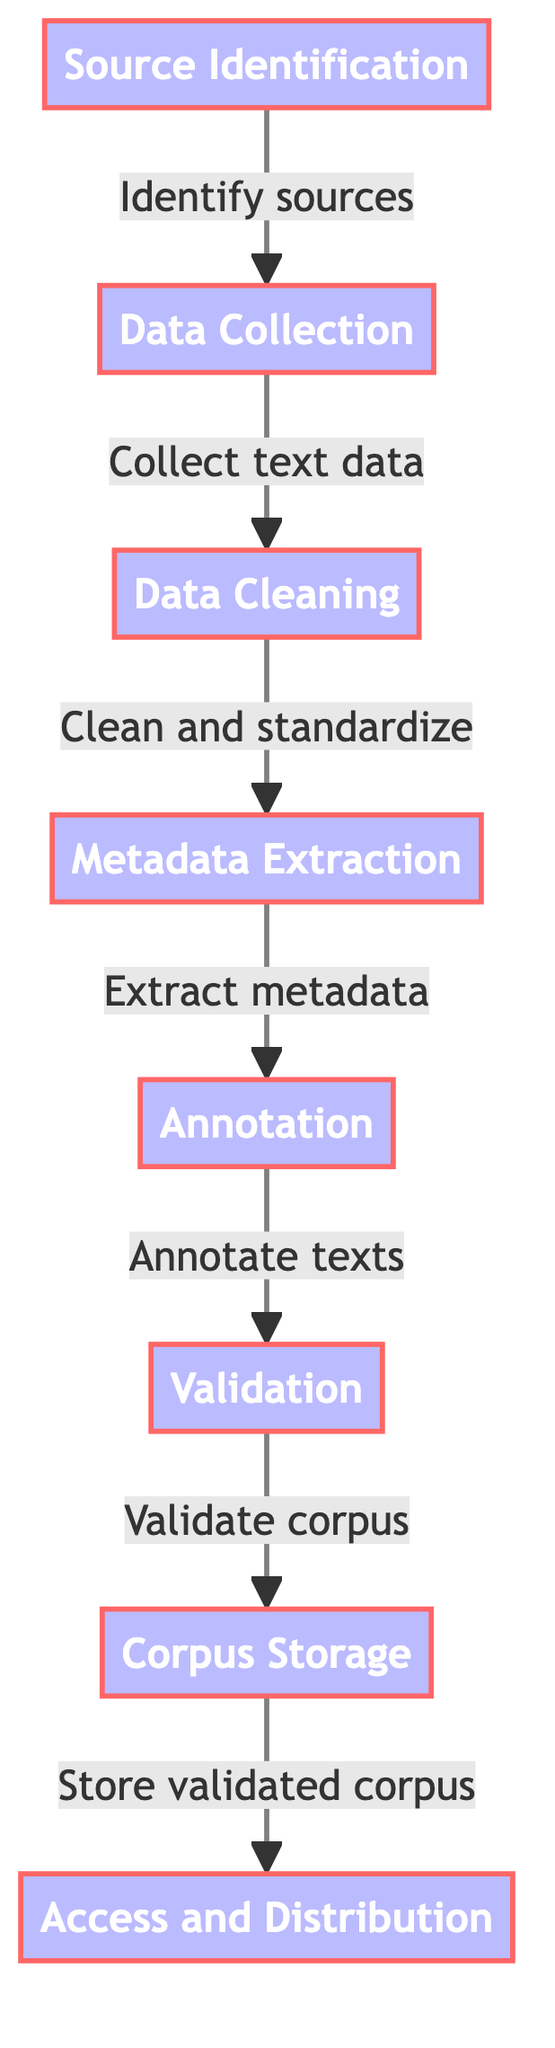What is the first step in the process? The diagram shows that the first step is "Source Identification," as it is the topmost node in the flowchart and leads to the next process.
Answer: Source Identification What is the last step in the process? The final step listed in the diagram is "Access and Distribution," which has no subsequent steps leading from it.
Answer: Access and Distribution How many steps are there in total? By counting the nodes in the diagram, there are a total of eight steps, from "Source Identification" to "Access and Distribution."
Answer: Eight Which step involves cleaning the data? The step labeled "Data Cleaning" is specifically dedicated to the process of cleaning the data, as indicated in the diagram.
Answer: Data Cleaning What department handles metadata extraction? "Metadata Extraction" is the step in the process that specifically focuses on extracting metadata from the texts gathered.
Answer: Metadata Extraction How does the flow progress from Data Collection to Annotation? The flow progresses from "Data Collection" to "Data Cleaning," then to "Metadata Extraction," and finally to "Annotation," showing a sequential order of steps.
Answer: Data Cleaning, Metadata Extraction, Annotation What are the tools mentioned for annotation? The tools referenced for the annotation step include "GATE" and "BRAT," as noted in the description of that node.
Answer: GATE or BRAT What validates the annotated corpus? The "Validation" step is tasked with validating the annotated corpus, which is done via peer review and automated checks.
Answer: Validation How is the corpus stored after validation? The corpus is stored in a structured format like XML or JSON within databases such as MongoDB or PostgreSQL as part of the "Corpus Storage" step.
Answer: XML or JSON in MongoDB or PostgreSQL 